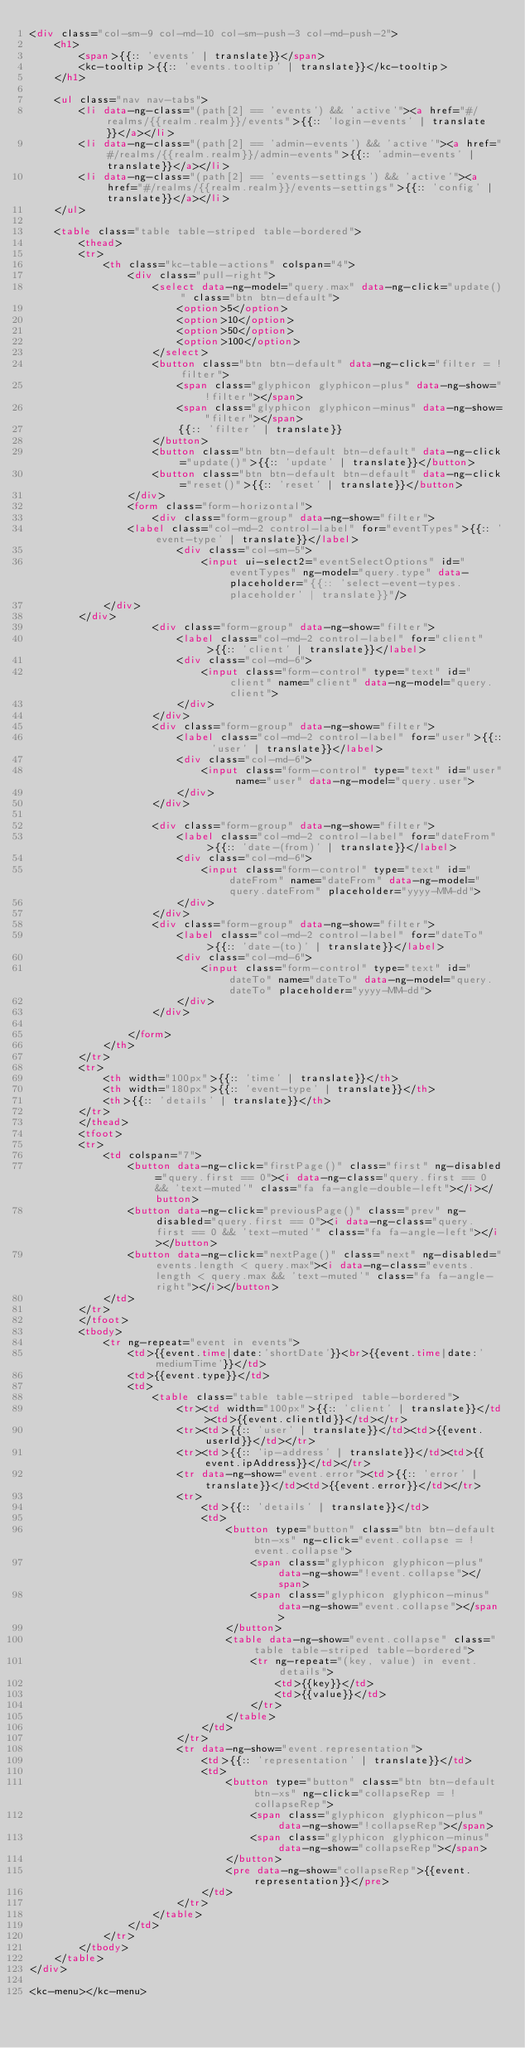<code> <loc_0><loc_0><loc_500><loc_500><_HTML_><div class="col-sm-9 col-md-10 col-sm-push-3 col-md-push-2">
    <h1>
        <span>{{:: 'events' | translate}}</span>
        <kc-tooltip>{{:: 'events.tooltip' | translate}}</kc-tooltip>
    </h1>

    <ul class="nav nav-tabs">
        <li data-ng-class="(path[2] == 'events') && 'active'"><a href="#/realms/{{realm.realm}}/events">{{:: 'login-events' | translate}}</a></li>
        <li data-ng-class="(path[2] == 'admin-events') && 'active'"><a href="#/realms/{{realm.realm}}/admin-events">{{:: 'admin-events' | translate}}</a></li>
        <li data-ng-class="(path[2] == 'events-settings') && 'active'"><a href="#/realms/{{realm.realm}}/events-settings">{{:: 'config' | translate}}</a></li>
    </ul>

    <table class="table table-striped table-bordered">
        <thead>
        <tr>
            <th class="kc-table-actions" colspan="4">
                <div class="pull-right">
                    <select data-ng-model="query.max" data-ng-click="update()" class="btn btn-default">
                        <option>5</option>
                        <option>10</option>
                        <option>50</option>
                        <option>100</option>
                    </select>
                    <button class="btn btn-default" data-ng-click="filter = !filter">
                        <span class="glyphicon glyphicon-plus" data-ng-show="!filter"></span>
                        <span class="glyphicon glyphicon-minus" data-ng-show="filter"></span>
                        {{:: 'filter' | translate}}
                    </button>
                    <button class="btn btn-default btn-default" data-ng-click="update()">{{:: 'update' | translate}}</button>
                    <button class="btn btn-default btn-default" data-ng-click="reset()">{{:: 'reset' | translate}}</button>
                </div>
                <form class="form-horizontal">
                    <div class="form-group" data-ng-show="filter">
                <label class="col-md-2 control-label" for="eventTypes">{{:: 'event-type' | translate}}</label>
                        <div class="col-sm-5">
                            <input ui-select2="eventSelectOptions" id="eventTypes" ng-model="query.type" data-placeholder="{{:: 'select-event-types.placeholder' | translate}}"/>
            </div>
        </div>
                    <div class="form-group" data-ng-show="filter">
                        <label class="col-md-2 control-label" for="client">{{:: 'client' | translate}}</label>
                        <div class="col-md-6">
                            <input class="form-control" type="text" id="client" name="client" data-ng-model="query.client">
                        </div>
                    </div>
                    <div class="form-group" data-ng-show="filter">
                        <label class="col-md-2 control-label" for="user">{{:: 'user' | translate}}</label>
                        <div class="col-md-6">
                            <input class="form-control" type="text" id="user" name="user" data-ng-model="query.user">
                        </div>
                    </div>

                    <div class="form-group" data-ng-show="filter">
                        <label class="col-md-2 control-label" for="dateFrom">{{:: 'date-(from)' | translate}}</label>
                        <div class="col-md-6">
                            <input class="form-control" type="text" id="dateFrom" name="dateFrom" data-ng-model="query.dateFrom" placeholder="yyyy-MM-dd">
                        </div>
                    </div>
                    <div class="form-group" data-ng-show="filter">
                        <label class="col-md-2 control-label" for="dateTo">{{:: 'date-(to)' | translate}}</label>
                        <div class="col-md-6">
                            <input class="form-control" type="text" id="dateTo" name="dateTo" data-ng-model="query.dateTo" placeholder="yyyy-MM-dd">
                        </div>
                    </div>

                </form>
            </th>
        </tr>
        <tr>
            <th width="100px">{{:: 'time' | translate}}</th>
            <th width="180px">{{:: 'event-type' | translate}}</th>
            <th>{{:: 'details' | translate}}</th>
        </tr>
        </thead>
        <tfoot>
        <tr>
            <td colspan="7">
                <button data-ng-click="firstPage()" class="first" ng-disabled="query.first == 0"><i data-ng-class="query.first == 0 && 'text-muted'" class="fa fa-angle-double-left"></i></button>
                <button data-ng-click="previousPage()" class="prev" ng-disabled="query.first == 0"><i data-ng-class="query.first == 0 && 'text-muted'" class="fa fa-angle-left"></i></button>
                <button data-ng-click="nextPage()" class="next" ng-disabled="events.length < query.max"><i data-ng-class="events.length < query.max && 'text-muted'" class="fa fa-angle-right"></i></button>
            </td>
        </tr>
        </tfoot>
        <tbody>
            <tr ng-repeat="event in events">
                <td>{{event.time|date:'shortDate'}}<br>{{event.time|date:'mediumTime'}}</td>
                <td>{{event.type}}</td>
                <td>
                    <table class="table table-striped table-bordered">
                        <tr><td width="100px">{{:: 'client' | translate}}</td><td>{{event.clientId}}</td></tr>
                        <tr><td>{{:: 'user' | translate}}</td><td>{{event.userId}}</td></tr>
                        <tr><td>{{:: 'ip-address' | translate}}</td><td>{{event.ipAddress}}</td></tr>
                        <tr data-ng-show="event.error"><td>{{:: 'error' | translate}}</td><td>{{event.error}}</td></tr>
                        <tr>
                            <td>{{:: 'details' | translate}}</td>
                            <td>
                                <button type="button" class="btn btn-default btn-xs" ng-click="event.collapse = !event.collapse">
                                    <span class="glyphicon glyphicon-plus" data-ng-show="!event.collapse"></span>
                                    <span class="glyphicon glyphicon-minus" data-ng-show="event.collapse"></span>
                                </button>
                                <table data-ng-show="event.collapse" class="table table-striped table-bordered">
                                    <tr ng-repeat="(key, value) in event.details">
                                        <td>{{key}}</td>
                                        <td>{{value}}</td>
                                    </tr>
                                </table>
                            </td>
                        </tr>
                        <tr data-ng-show="event.representation">
                            <td>{{:: 'representation' | translate}}</td>
                            <td>
                                <button type="button" class="btn btn-default btn-xs" ng-click="collapseRep = !collapseRep">
                                    <span class="glyphicon glyphicon-plus" data-ng-show="!collapseRep"></span>
                                    <span class="glyphicon glyphicon-minus" data-ng-show="collapseRep"></span>
                                </button>
                                <pre data-ng-show="collapseRep">{{event.representation}}</pre>
                            </td>
                        </tr>
                    </table>
                </td>
            </tr>
        </tbody>
    </table>
</div>

<kc-menu></kc-menu></code> 